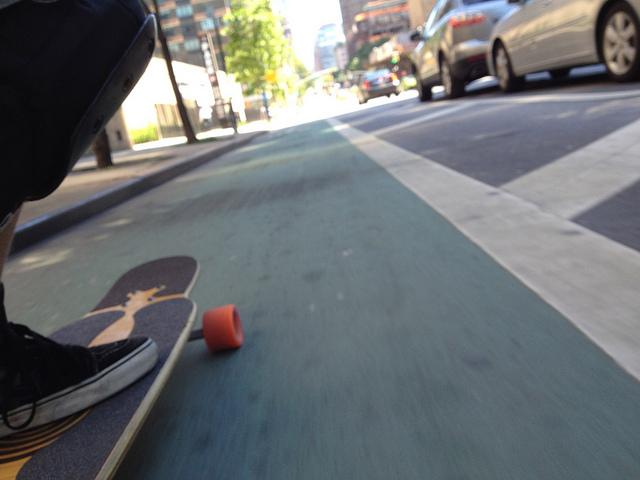What is on top of the skateboard? shoe 